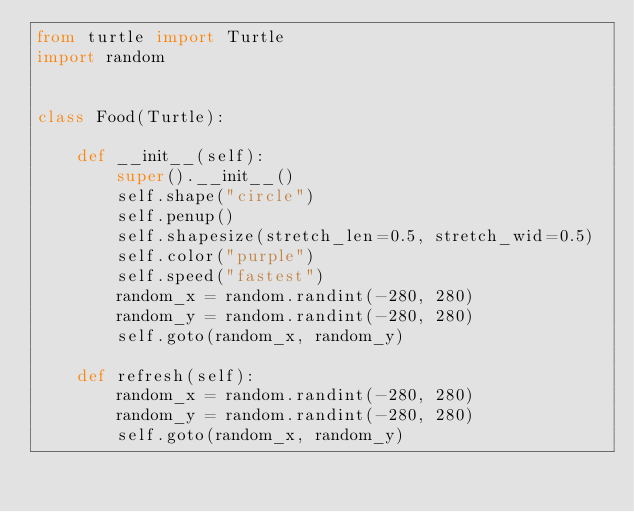Convert code to text. <code><loc_0><loc_0><loc_500><loc_500><_Python_>from turtle import Turtle
import random


class Food(Turtle):

    def __init__(self):
        super().__init__()
        self.shape("circle")
        self.penup()
        self.shapesize(stretch_len=0.5, stretch_wid=0.5)
        self.color("purple")
        self.speed("fastest")
        random_x = random.randint(-280, 280)
        random_y = random.randint(-280, 280)
        self.goto(random_x, random_y)

    def refresh(self):
        random_x = random.randint(-280, 280)
        random_y = random.randint(-280, 280)
        self.goto(random_x, random_y)
</code> 